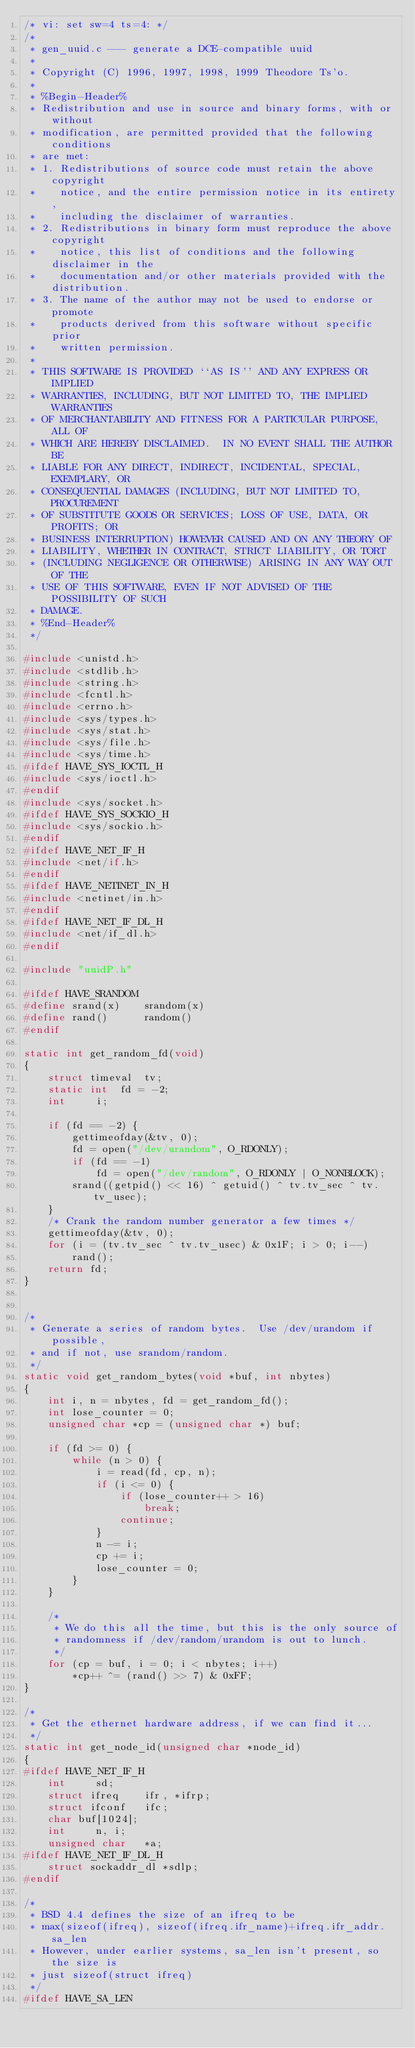<code> <loc_0><loc_0><loc_500><loc_500><_C_>/* vi: set sw=4 ts=4: */
/*
 * gen_uuid.c --- generate a DCE-compatible uuid
 *
 * Copyright (C) 1996, 1997, 1998, 1999 Theodore Ts'o.
 *
 * %Begin-Header%
 * Redistribution and use in source and binary forms, with or without
 * modification, are permitted provided that the following conditions
 * are met:
 * 1. Redistributions of source code must retain the above copyright
 *    notice, and the entire permission notice in its entirety,
 *    including the disclaimer of warranties.
 * 2. Redistributions in binary form must reproduce the above copyright
 *    notice, this list of conditions and the following disclaimer in the
 *    documentation and/or other materials provided with the distribution.
 * 3. The name of the author may not be used to endorse or promote
 *    products derived from this software without specific prior
 *    written permission.
 *
 * THIS SOFTWARE IS PROVIDED ``AS IS'' AND ANY EXPRESS OR IMPLIED
 * WARRANTIES, INCLUDING, BUT NOT LIMITED TO, THE IMPLIED WARRANTIES
 * OF MERCHANTABILITY AND FITNESS FOR A PARTICULAR PURPOSE, ALL OF
 * WHICH ARE HEREBY DISCLAIMED.  IN NO EVENT SHALL THE AUTHOR BE
 * LIABLE FOR ANY DIRECT, INDIRECT, INCIDENTAL, SPECIAL, EXEMPLARY, OR
 * CONSEQUENTIAL DAMAGES (INCLUDING, BUT NOT LIMITED TO, PROCUREMENT
 * OF SUBSTITUTE GOODS OR SERVICES; LOSS OF USE, DATA, OR PROFITS; OR
 * BUSINESS INTERRUPTION) HOWEVER CAUSED AND ON ANY THEORY OF
 * LIABILITY, WHETHER IN CONTRACT, STRICT LIABILITY, OR TORT
 * (INCLUDING NEGLIGENCE OR OTHERWISE) ARISING IN ANY WAY OUT OF THE
 * USE OF THIS SOFTWARE, EVEN IF NOT ADVISED OF THE POSSIBILITY OF SUCH
 * DAMAGE.
 * %End-Header%
 */

#include <unistd.h>
#include <stdlib.h>
#include <string.h>
#include <fcntl.h>
#include <errno.h>
#include <sys/types.h>
#include <sys/stat.h>
#include <sys/file.h>
#include <sys/time.h>
#ifdef HAVE_SYS_IOCTL_H
#include <sys/ioctl.h>
#endif
#include <sys/socket.h>
#ifdef HAVE_SYS_SOCKIO_H
#include <sys/sockio.h>
#endif
#ifdef HAVE_NET_IF_H
#include <net/if.h>
#endif
#ifdef HAVE_NETINET_IN_H
#include <netinet/in.h>
#endif
#ifdef HAVE_NET_IF_DL_H
#include <net/if_dl.h>
#endif

#include "uuidP.h"

#ifdef HAVE_SRANDOM
#define srand(x)	srandom(x)
#define rand()		random()
#endif

static int get_random_fd(void)
{
	struct timeval	tv;
	static int	fd = -2;
	int		i;

	if (fd == -2) {
		gettimeofday(&tv, 0);
		fd = open("/dev/urandom", O_RDONLY);
		if (fd == -1)
			fd = open("/dev/random", O_RDONLY | O_NONBLOCK);
		srand((getpid() << 16) ^ getuid() ^ tv.tv_sec ^ tv.tv_usec);
	}
	/* Crank the random number generator a few times */
	gettimeofday(&tv, 0);
	for (i = (tv.tv_sec ^ tv.tv_usec) & 0x1F; i > 0; i--)
		rand();
	return fd;
}


/*
 * Generate a series of random bytes.  Use /dev/urandom if possible,
 * and if not, use srandom/random.
 */
static void get_random_bytes(void *buf, int nbytes)
{
	int i, n = nbytes, fd = get_random_fd();
	int lose_counter = 0;
	unsigned char *cp = (unsigned char *) buf;

	if (fd >= 0) {
		while (n > 0) {
			i = read(fd, cp, n);
			if (i <= 0) {
				if (lose_counter++ > 16)
					break;
				continue;
			}
			n -= i;
			cp += i;
			lose_counter = 0;
		}
	}

	/*
	 * We do this all the time, but this is the only source of
	 * randomness if /dev/random/urandom is out to lunch.
	 */
	for (cp = buf, i = 0; i < nbytes; i++)
		*cp++ ^= (rand() >> 7) & 0xFF;
}

/*
 * Get the ethernet hardware address, if we can find it...
 */
static int get_node_id(unsigned char *node_id)
{
#ifdef HAVE_NET_IF_H
	int		sd;
	struct ifreq	ifr, *ifrp;
	struct ifconf	ifc;
	char buf[1024];
	int		n, i;
	unsigned char	*a;
#ifdef HAVE_NET_IF_DL_H
	struct sockaddr_dl *sdlp;
#endif

/*
 * BSD 4.4 defines the size of an ifreq to be
 * max(sizeof(ifreq), sizeof(ifreq.ifr_name)+ifreq.ifr_addr.sa_len
 * However, under earlier systems, sa_len isn't present, so the size is
 * just sizeof(struct ifreq)
 */
#ifdef HAVE_SA_LEN</code> 